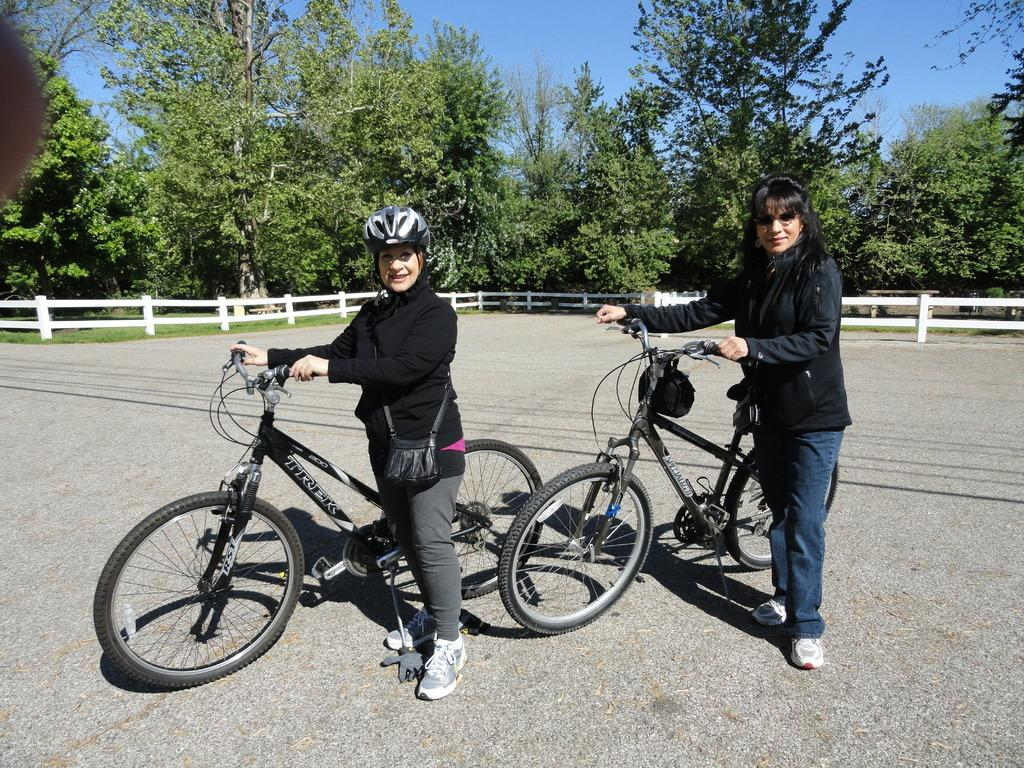Who are the main subjects in the image? There are two ladies in the center of the image. What are the ladies holding in their hands? The ladies are holding bicycles in their hands. What can be seen in the background of the image? There are trees, a boundary, and the sky visible in the background of the image. How many snails can be seen crawling on the boundary in the image? There are no snails visible in the image; the focus is on the two ladies holding bicycles. What type of business is being conducted in the alley in the image? There is no alley or business present in the image. 